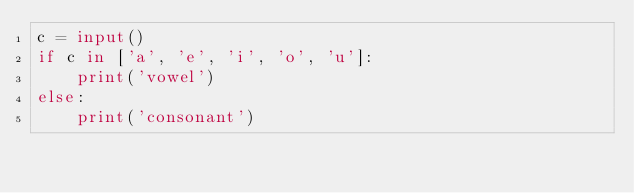Convert code to text. <code><loc_0><loc_0><loc_500><loc_500><_Python_>c = input()
if c in ['a', 'e', 'i', 'o', 'u']:
    print('vowel')
else:
    print('consonant')
</code> 